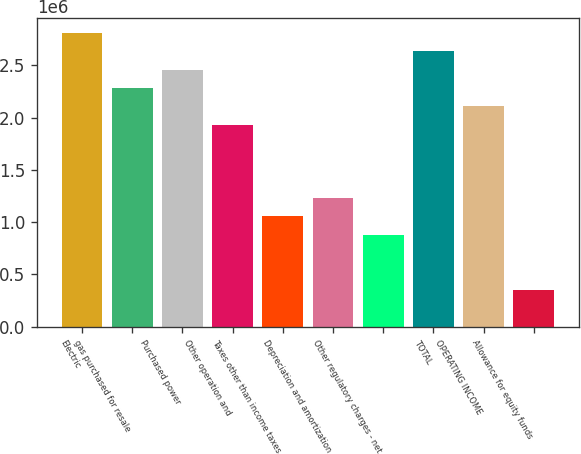Convert chart. <chart><loc_0><loc_0><loc_500><loc_500><bar_chart><fcel>Electric<fcel>gas purchased for resale<fcel>Purchased power<fcel>Other operation and<fcel>Taxes other than income taxes<fcel>Depreciation and amortization<fcel>Other regulatory charges - net<fcel>TOTAL<fcel>OPERATING INCOME<fcel>Allowance for equity funds<nl><fcel>2.80995e+06<fcel>2.28358e+06<fcel>2.45904e+06<fcel>1.93266e+06<fcel>1.05536e+06<fcel>1.23082e+06<fcel>879904<fcel>2.63449e+06<fcel>2.10812e+06<fcel>353527<nl></chart> 